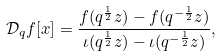<formula> <loc_0><loc_0><loc_500><loc_500>\mathcal { D } _ { q } f [ x ] = \frac { f ( q ^ { \frac { 1 } { 2 } } z ) - f ( q ^ { - \frac { 1 } { 2 } } z ) } { \iota ( q ^ { \frac { 1 } { 2 } } z ) - \iota ( q ^ { - \frac { 1 } { 2 } } z ) } ,</formula> 